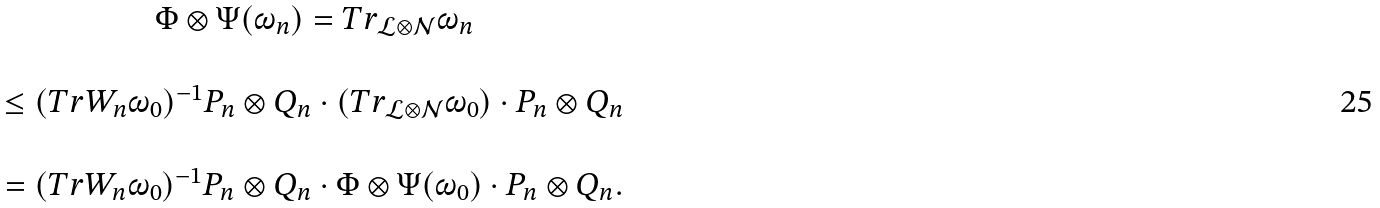<formula> <loc_0><loc_0><loc_500><loc_500>\begin{array} { c } \Phi \otimes \Psi ( \omega _ { n } ) = T r _ { \mathcal { L } \otimes \mathcal { N } } \omega _ { n } \\ \\ \leq ( T r W _ { n } \omega _ { 0 } ) ^ { - 1 } P _ { n } \otimes Q _ { n } \cdot ( T r _ { \mathcal { L } \otimes \mathcal { N } } \omega _ { 0 } ) \cdot P _ { n } \otimes Q _ { n } \\ \\ = ( T r W _ { n } \omega _ { 0 } ) ^ { - 1 } P _ { n } \otimes Q _ { n } \cdot \Phi \otimes \Psi ( \omega _ { 0 } ) \cdot P _ { n } \otimes Q _ { n } . \end{array}</formula> 